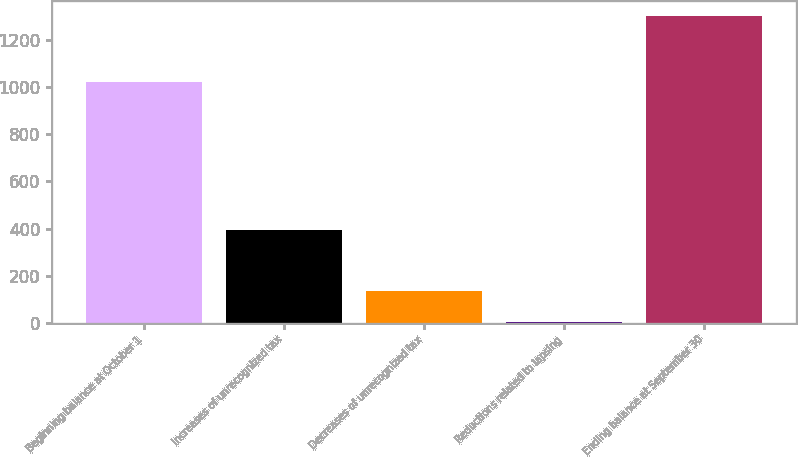Convert chart to OTSL. <chart><loc_0><loc_0><loc_500><loc_500><bar_chart><fcel>Beginning balance at October 1<fcel>Increases of unrecognized tax<fcel>Decreases of unrecognized tax<fcel>Reductions related to lapsing<fcel>Ending balance at September 30<nl><fcel>1023<fcel>393.7<fcel>133.9<fcel>4<fcel>1303<nl></chart> 